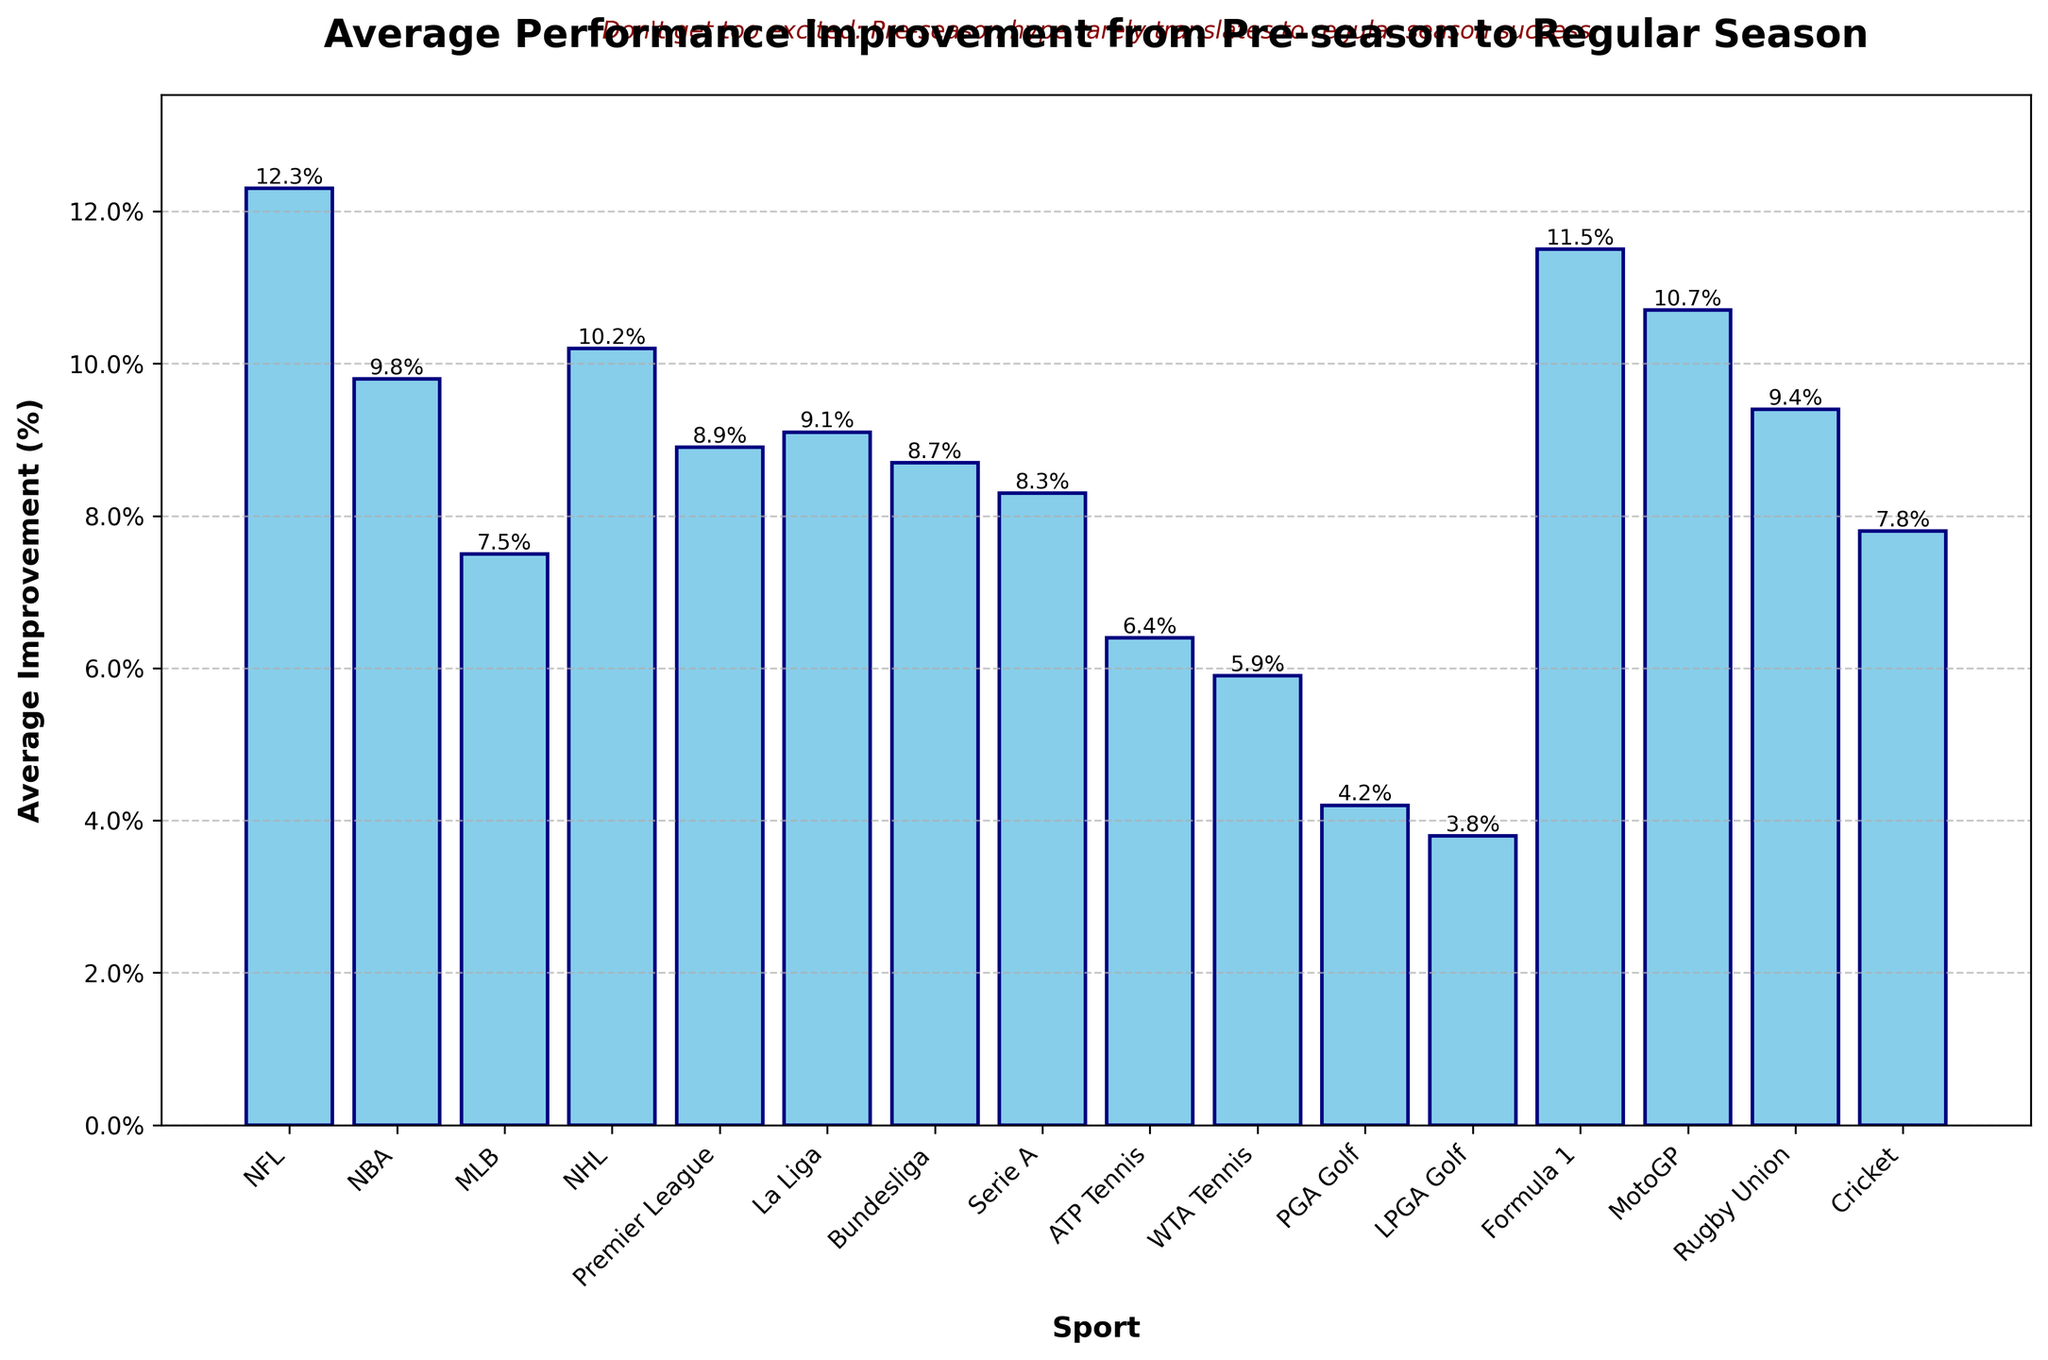Which sport has the highest average performance improvement? The bar chart shows the performance improvements with NFL having the highest bar.
Answer: NFL What's the difference in average performance improvement between NFL and WTA Tennis? The bar for NFL is 12.3% and for WTA Tennis is 5.9%. Subtracting these values gives the difference: 12.3% - 5.9% = 6.4%.
Answer: 6.4% Which sport has a lower average performance improvement, Cricket or Serie A? The bar for Cricket is 7.8% and for Serie A is 8.3%. Thus, Cricket is lower.
Answer: Cricket What are the two sports with the closest average performance improvement percentages? By examining the bars, NBA and La Liga have very close improvements of 9.8% and 9.1% respectively.
Answer: NBA and La Liga How much higher is the performance improvement in Formula 1 compared to PGA Golf? Formula 1 shows a 11.5% improvement and PGA Golf shows a 4.2% improvement. The difference is 11.5% - 4.2% = 7.3%.
Answer: 7.3% What's the total average performance improvement for the four sports with the highest values? Sum the percentages for the highest values: NFL (12.3%), Formula 1 (11.5%), MotoGP (10.7%), and NHL (10.2%). So, 12.3% + 11.5% + 10.7% + 10.2% = 44.7%.
Answer: 44.7% How does the average performance improvement of ATP Tennis compare to Bundesliga and Serie A combined? ATP Tennis is 6.4%. Bundesliga and Serie A combined are 8.7% + 8.3% = 17%. So, 6.4% compared to 17%.
Answer: Less What's the average of the performance improvements across all sports listed? Sum all percentages and divide by number of sports (16). (12.3 + 9.8 + 7.5 + 10.2 + 8.9 + 9.1 + 8.7 + 8.3 + 6.4 + 5.9 + 4.2 + 3.8 + 11.5 + 10.7 + 9.4 + 7.8) / 16 = 8.3%.
Answer: 8.3% Which sport's performance improvement lies closest to the average for all sports? The average was calculated to be 8.3%. Serie A also has an improvement of 8.3%, this matches the average directly.
Answer: Serie A 